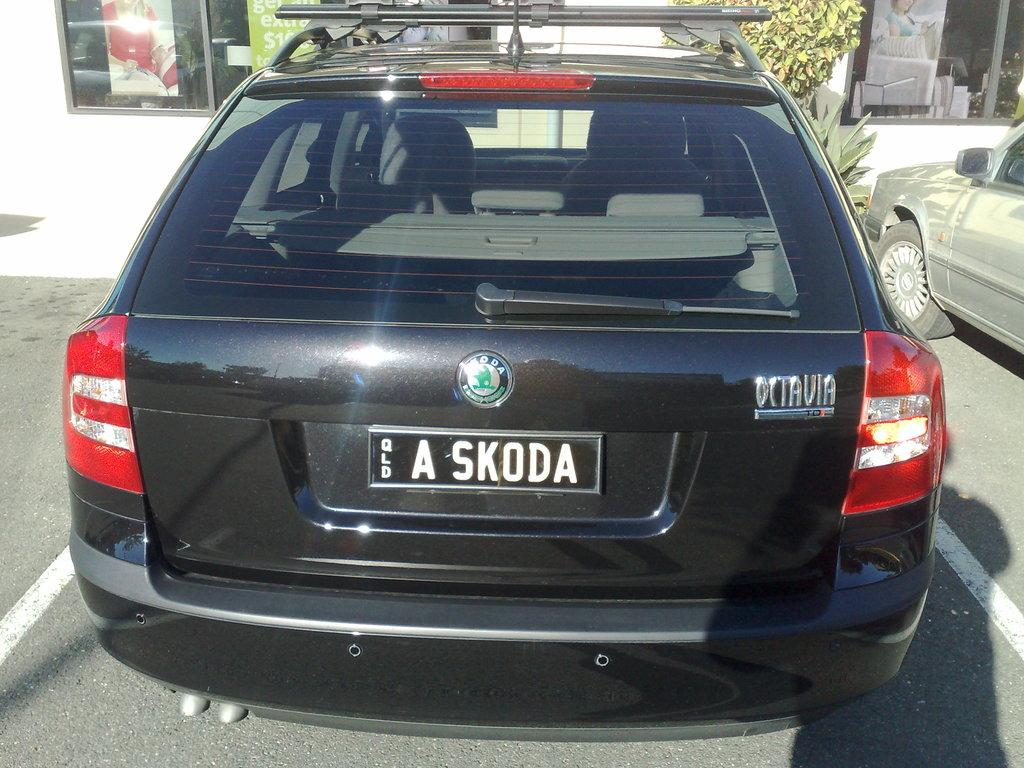<image>
Relay a brief, clear account of the picture shown. The license plate on an Octavia reads A SKODA. 